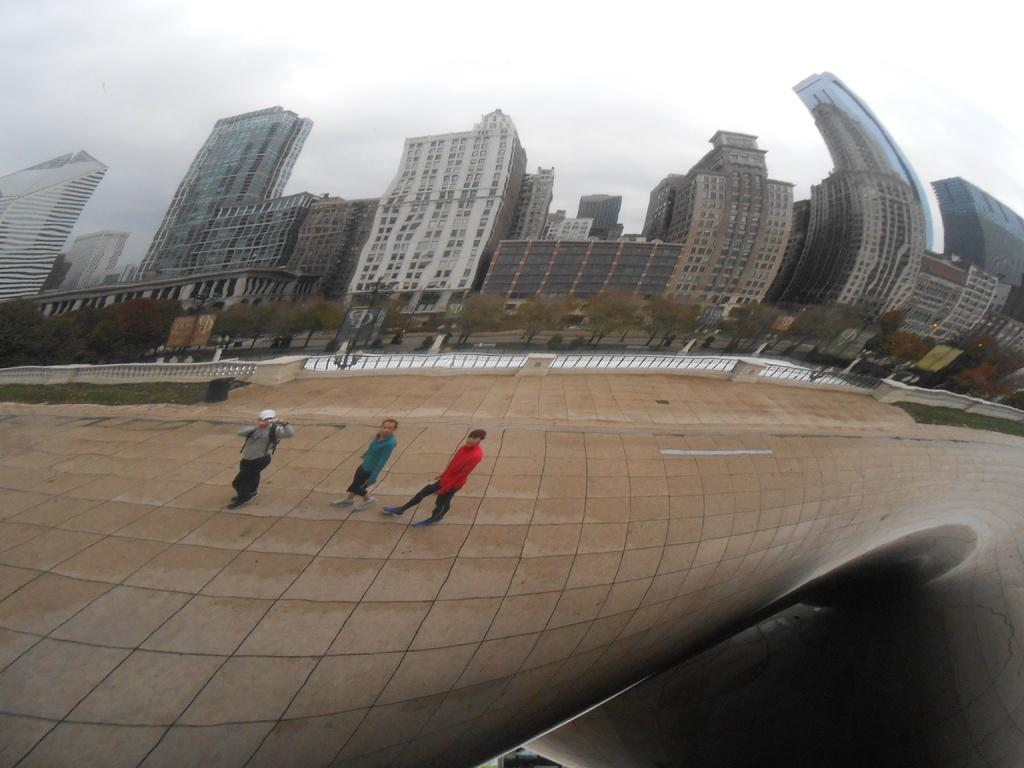How many people are walking in the image? There are three persons walking in the image. What is the surface on which the persons are walking? The persons are walking on the ground. What type of vegetation can be seen in the image? There are trees in the image. What type of structure is present in the image? There is a fence in the image. What type of buildings can be seen in the image? There are buildings with windows in the image. What is visible in the background of the image? The sky with clouds is visible in the background of the image. What invention can be seen in the hands of the persons walking in the image? There is no specific invention visible in the hands of the persons walking in the image. 